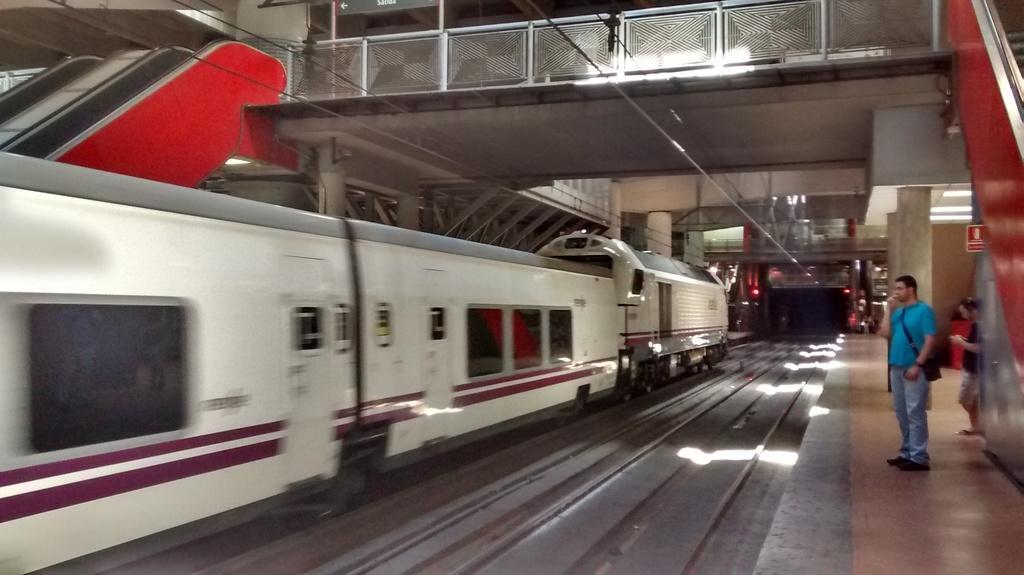How would you summarize this image in a sentence or two? This image is taken at the railway station. In this image we can see there are two persons standing on the pavement of the station, in front of them there is a train on the track. On the other sides of the train there are escalators. At the top of the image there is a foot over bridge. 